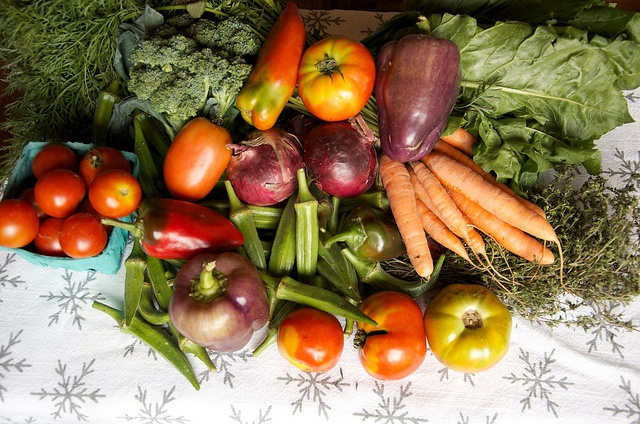Describe the objects in this image and their specific colors. I can see dining table in darkgreen, white, darkgray, and lightgray tones, bowl in darkgreen, maroon, black, brown, and red tones, carrot in darkgreen, orange, tan, and red tones, broccoli in darkgreen, black, and olive tones, and carrot in darkgreen, orange, brown, red, and salmon tones in this image. 